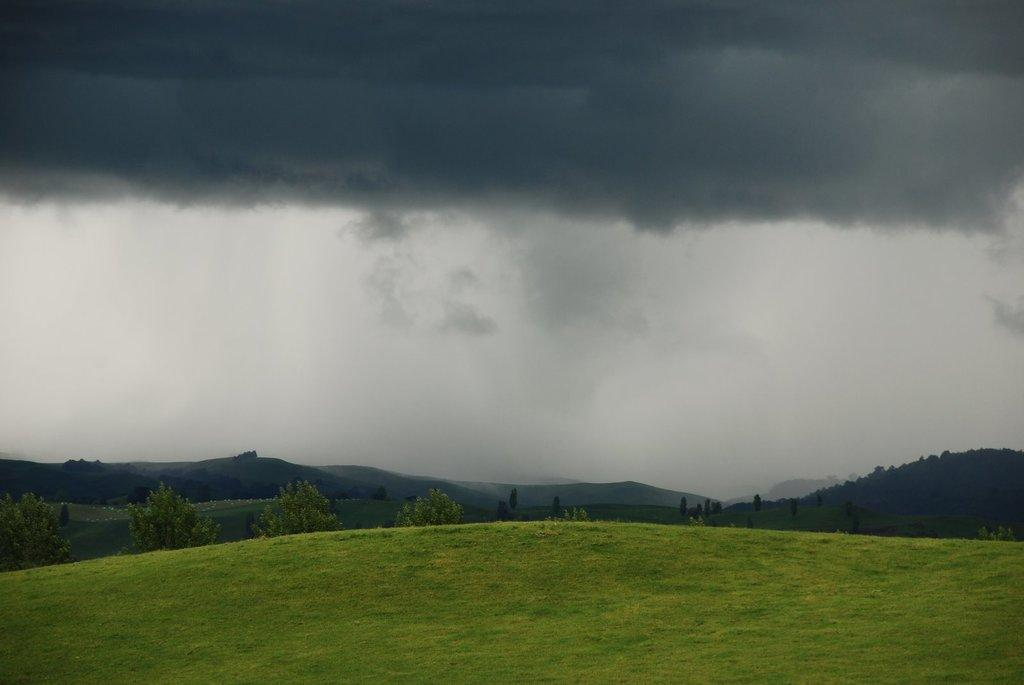What can be seen in the sky in the image? The sky with clouds is visible in the image. What type of natural features can be seen in the image? There are hills and trees present in the image. What is visible at the bottom of the image? The ground is visible in the image. What type of engine is visible in the image? There is no engine present in the image. Is there a party happening in the image? There is no indication of a party in the image. 